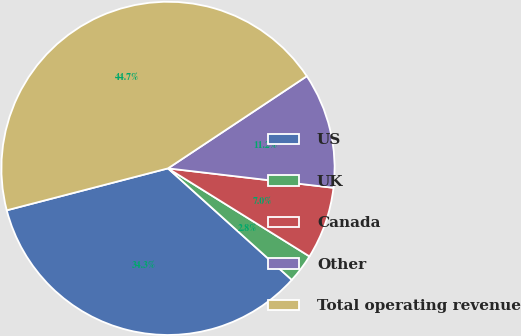<chart> <loc_0><loc_0><loc_500><loc_500><pie_chart><fcel>US<fcel>UK<fcel>Canada<fcel>Other<fcel>Total operating revenue<nl><fcel>34.28%<fcel>2.81%<fcel>7.0%<fcel>11.19%<fcel>44.72%<nl></chart> 